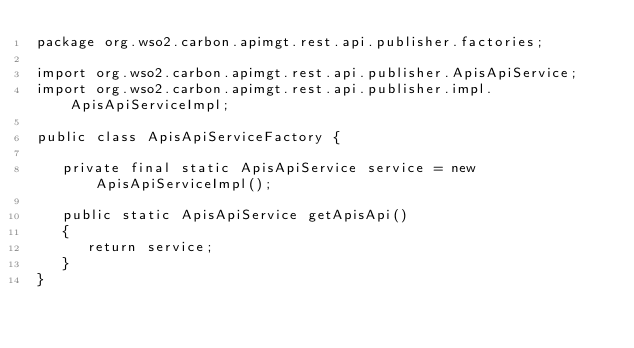Convert code to text. <code><loc_0><loc_0><loc_500><loc_500><_Java_>package org.wso2.carbon.apimgt.rest.api.publisher.factories;

import org.wso2.carbon.apimgt.rest.api.publisher.ApisApiService;
import org.wso2.carbon.apimgt.rest.api.publisher.impl.ApisApiServiceImpl;

public class ApisApiServiceFactory {

   private final static ApisApiService service = new ApisApiServiceImpl();

   public static ApisApiService getApisApi()
   {
      return service;
   }
}
</code> 